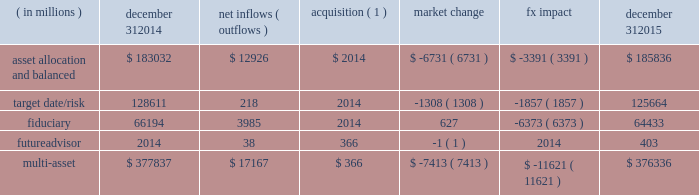Long-term product offerings include active and index strategies .
Our active strategies seek to earn attractive returns in excess of a market benchmark or performance hurdle while maintaining an appropriate risk profile .
We offer two types of active strategies : those that rely primarily on fundamental research and those that utilize primarily quantitative models to drive portfolio construction .
In contrast , index strategies seek to closely track the returns of a corresponding index , generally by investing in substantially the same underlying securities within the index or in a subset of those securities selected to approximate a similar risk and return profile of the index .
Index strategies include both our non-etf index products and ishares etfs .
Althoughmany clients use both active and index strategies , the application of these strategies may differ .
For example , clients may use index products to gain exposure to a market or asset class .
In addition , institutional non-etf index assignments tend to be very large ( multi-billion dollars ) and typically reflect low fee rates .
This has the potential to exaggerate the significance of net flows in institutional index products on blackrock 2019s revenues and earnings .
Equity year-end 2015 equity aum totaled $ 2.424 trillion , reflecting net inflows of $ 52.8 billion .
Net inflows included $ 78.4 billion and $ 4.2 billion into ishares and active products , respectively .
Ishares net inflows were driven by the core series and flows into broad developed market equity exposures , and active net inflows reflected demand for international equities .
Ishares and active net inflows were partially offset by non-etf index net outflows of $ 29.8 billion .
Blackrock 2019s effective fee rates fluctuate due to changes in aummix .
Approximately half of blackrock 2019s equity aum is tied to international markets , including emerging markets , which tend to have higher fee rates than u.s .
Equity strategies .
Accordingly , fluctuations in international equity markets , which do not consistently move in tandemwith u.s .
Markets , may have a greater impact on blackrock 2019s effective equity fee rates and revenues .
Fixed income fixed income aum ended 2015 at $ 1.422 trillion , increasing $ 28.7 billion , or 2% ( 2 % ) , from december 31 , 2014 .
The increase in aum reflected $ 76.9 billion in net inflows , partially offset by $ 48.2 billion in net market depreciation and foreign exchange movements .
In 2015 , active net inflows of $ 35.9 billion were diversified across fixed income offerings , with strong flows into our unconstrained , total return and high yield strategies .
Flagship funds in these product areas include our unconstrained strategic income opportunities and fixed income strategies funds , with net inflows of $ 7.0 billion and $ 3.7 billion , respectively ; our total return fund with net inflows of $ 2.7 billion ; and our high yield bond fund with net inflows of $ 3.5 billion .
Fixed income ishares net inflows of $ 50.3 billion were led by flows into core , corporate and high yield bond funds .
Active and ishares net inflows were partially offset by non-etf index net outflows of $ 9.3 billion .
Multi-asset class blackrock 2019s multi-asset class teammanages a variety of balanced funds and bespoke mandates for a diversified client base that leverages our broad investment expertise in global equities , bonds , currencies and commodities , and our extensive risk management capabilities .
Investment solutions might include a combination of long-only portfolios and alternative investments as well as tactical asset allocation overlays .
Component changes in multi-asset class aum for 2015 are presented below .
( in millions ) december 31 , 2014 net inflows ( outflows ) acquisition ( 1 ) market change fx impact december 31 , 2015 asset allocation and balanced $ 183032 $ 12926 $ 2014 $ ( 6731 ) $ ( 3391 ) $ 185836 .
( 1 ) amounts represent $ 366 million of aum acquired in the futureadvisor acquisition in october 2015 .
The futureadvisor acquisition amount does not include aum that was held in ishares holdings .
Multi-asset class net inflows reflected ongoing institutional demand for our solutions-based advice with $ 17.4 billion of net inflows coming from institutional clients .
Defined contribution plans of institutional clients remained a significant driver of flows , and contributed $ 7.3 billion to institutional multi-asset class net new business in 2015 , primarily into target date and target risk product offerings .
Retail net outflows of $ 1.3 billion were primarily due to a large single-client transition out of mutual funds into a series of ishares across asset classes .
Notwithstanding this transition , retail flows reflected demand for our multi-asset income fund family , which raised $ 4.6 billion in 2015 .
The company 2019s multi-asset class strategies include the following : 2022 asset allocation and balanced products represented 49% ( 49 % ) of multi-asset class aum at year-end , with growth in aum driven by net new business of $ 12.9 billion .
These strategies combine equity , fixed income and alternative components for investors seeking a tailored solution relative to a specific benchmark and within a risk budget .
In certain cases , these strategies seek to minimize downside risk through diversification , derivatives strategies and tactical asset allocation decisions .
Flagship products in this category include our global allocation andmulti-asset income suites. .
What is the value of the effect what market change and fx impact had on asset allocation and balanced ? in million $ .? 
Computations: (6731 + 3391)
Answer: 10122.0. 